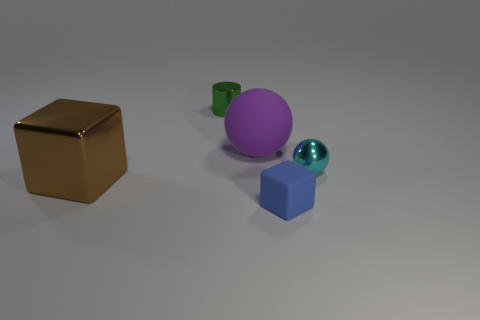Add 4 cyan things. How many objects exist? 9 Subtract all spheres. How many objects are left? 3 Add 2 metallic things. How many metallic things are left? 5 Add 5 rubber blocks. How many rubber blocks exist? 6 Subtract 0 cyan blocks. How many objects are left? 5 Subtract all large objects. Subtract all big brown objects. How many objects are left? 2 